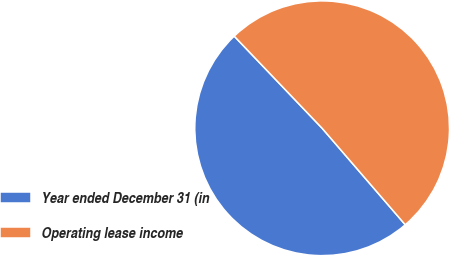<chart> <loc_0><loc_0><loc_500><loc_500><pie_chart><fcel>Year ended December 31 (in<fcel>Operating lease income<nl><fcel>49.19%<fcel>50.81%<nl></chart> 